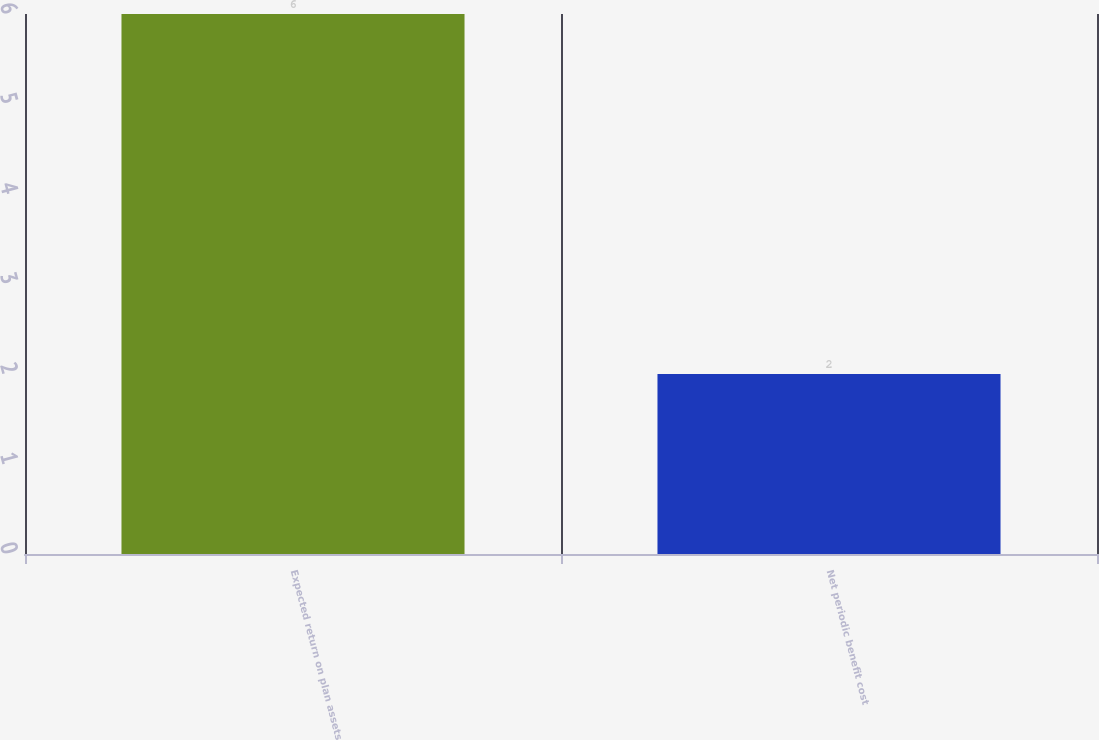<chart> <loc_0><loc_0><loc_500><loc_500><bar_chart><fcel>Expected return on plan assets<fcel>Net periodic benefit cost<nl><fcel>6<fcel>2<nl></chart> 